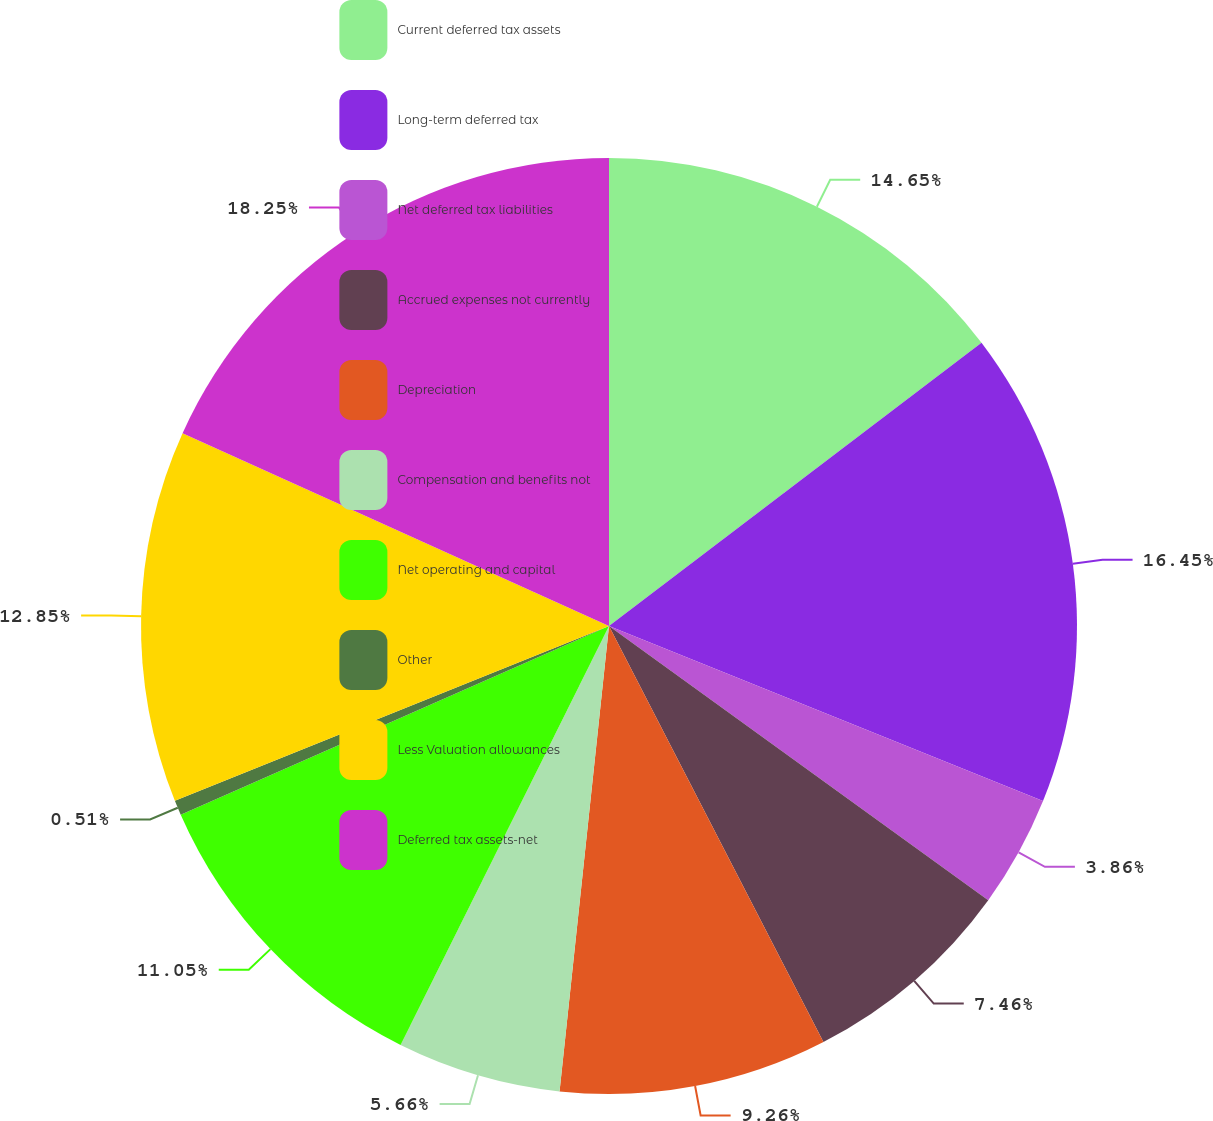Convert chart. <chart><loc_0><loc_0><loc_500><loc_500><pie_chart><fcel>Current deferred tax assets<fcel>Long-term deferred tax<fcel>Net deferred tax liabilities<fcel>Accrued expenses not currently<fcel>Depreciation<fcel>Compensation and benefits not<fcel>Net operating and capital<fcel>Other<fcel>Less Valuation allowances<fcel>Deferred tax assets-net<nl><fcel>14.65%<fcel>16.45%<fcel>3.86%<fcel>7.46%<fcel>9.26%<fcel>5.66%<fcel>11.05%<fcel>0.51%<fcel>12.85%<fcel>18.24%<nl></chart> 